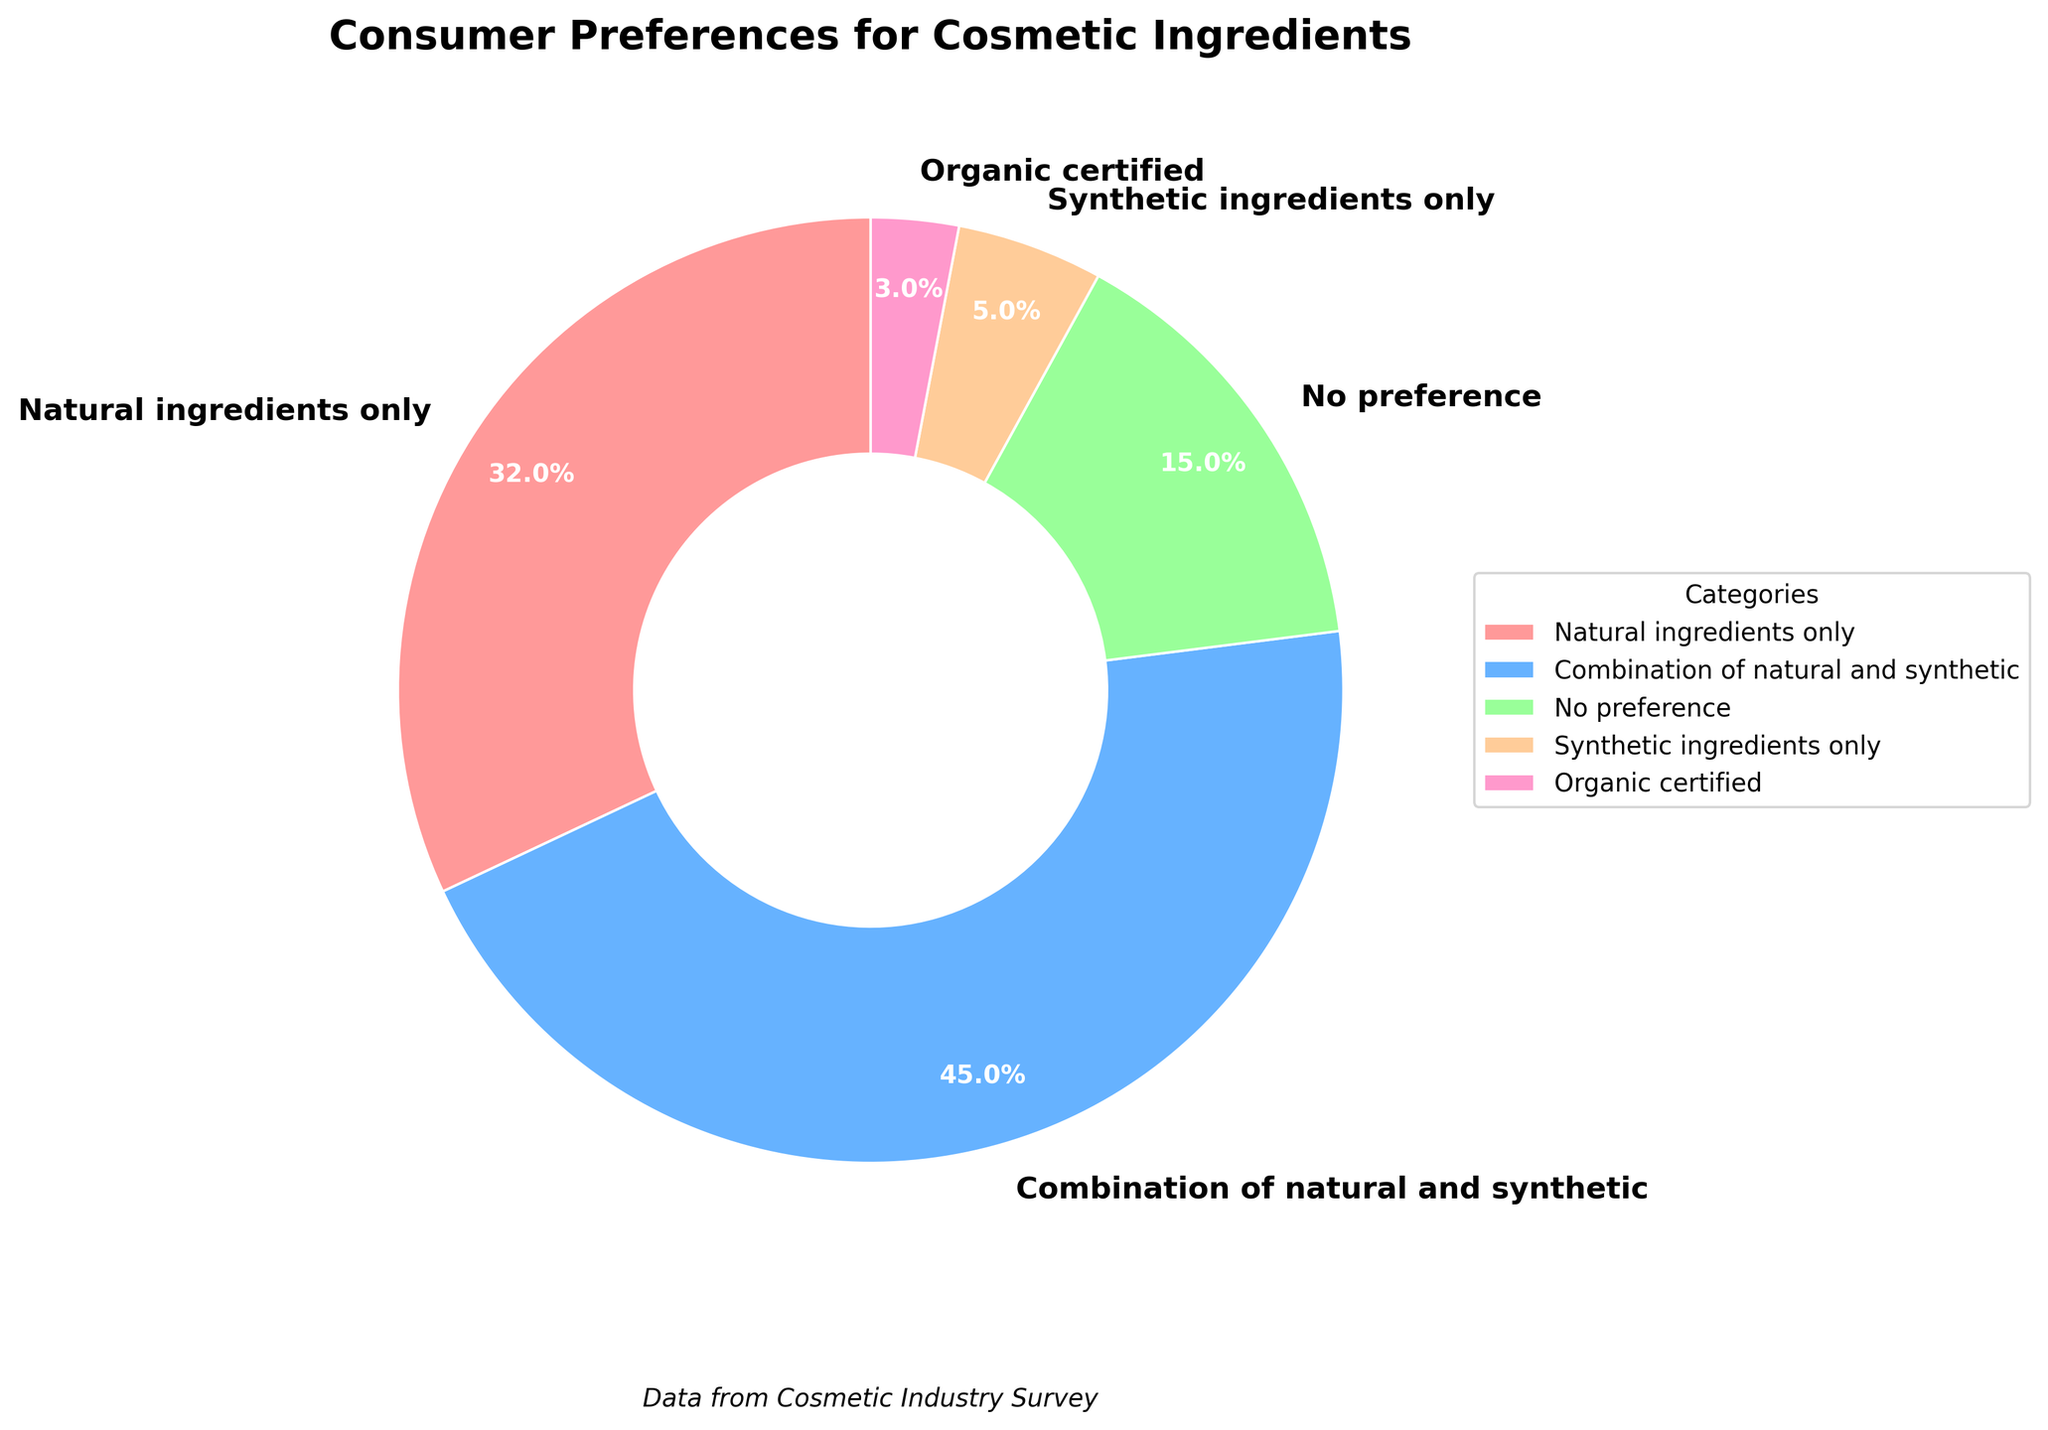What percentage of consumers have no preference between natural and synthetic ingredients? Look at the section labeled "No preference" in the pie chart. It is labeled with the percentage value.
Answer: 15% How many times greater is the percentage of consumers preferring a combination of natural and synthetic ingredients compared to those preferring only synthetic ingredients? Locate the percentage of consumers preferring a combination of natural and synthetic ingredients (45%) and those preferring only synthetic ingredients (5%). Calculate the ratio by dividing 45 by 5.
Answer: 9 times What's the total percentage of consumers who prefer some form of natural ingredients (either natural only, natural and synthetic combination, or organic certified)? Sum the percentages for "Natural ingredients only" (32%), "Combination of natural and synthetic" (45%), and "Organic certified" (3%).
Answer: 32% + 45% + 3% = 80% Which category has the smallest proportion of consumer preference? Identify the segment with the smallest percentage. The "Organic certified" category has the smallest proportion (3%).
Answer: Organic certified By how much does the percentage of consumers preferring natural ingredients only exceed those preferring synthetic ingredients only? Subtract the percentage of consumers preferring synthetic ingredients only (5%) from the percentage preferring natural ingredients only (32%).
Answer: 32% - 5% = 27% What fraction of the total preferences do consumers who prefer natural ingredients only and synthetic ingredients only together represent? Sum the percentages of "Natural ingredients only" (32%) and "Synthetic ingredients only" (5%), then express the sum as a fraction of 100%.
Answer: 32% + 5% = 37%, so the fraction is 37/100 or 0.37 Which category has the highest percentage of consumer preference, and what is that percentage? Identify the segment with the highest percentage, which is "Combination of natural and synthetic" at 45%.
Answer: Combination of natural and synthetic, 45% What is the difference in preference percentage between consumers who prefer natural ingredients only and those who indicate no preference? Subtract the percentage of "No preference" (15%) from "Natural ingredients only" (32%).
Answer: 32% - 15% = 17% How can you visually distinguish the category representing synthetic ingredients only in the pie chart? The pie chart segment for "Synthetic ingredients only" is visually distinct due to its color and label indicating "5%".
Answer: By its color and 5% label 